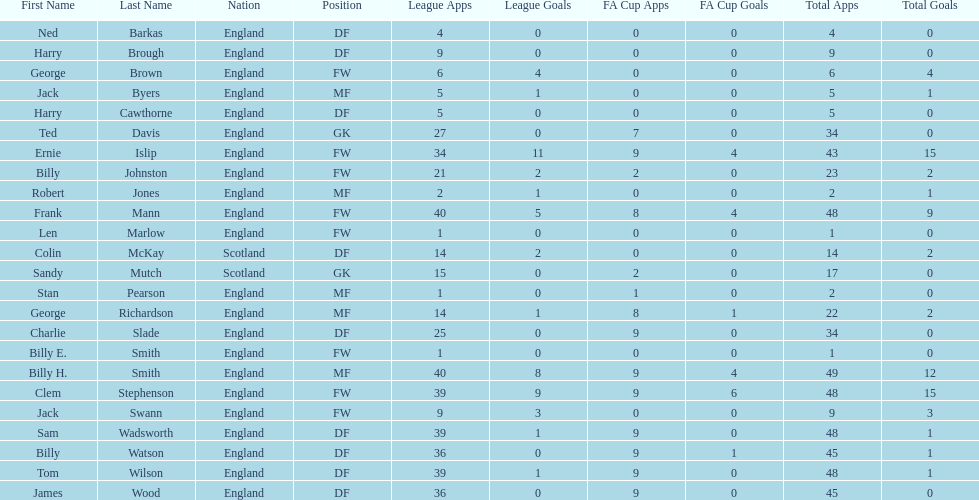What are the number of league apps ted davis has? 27. 